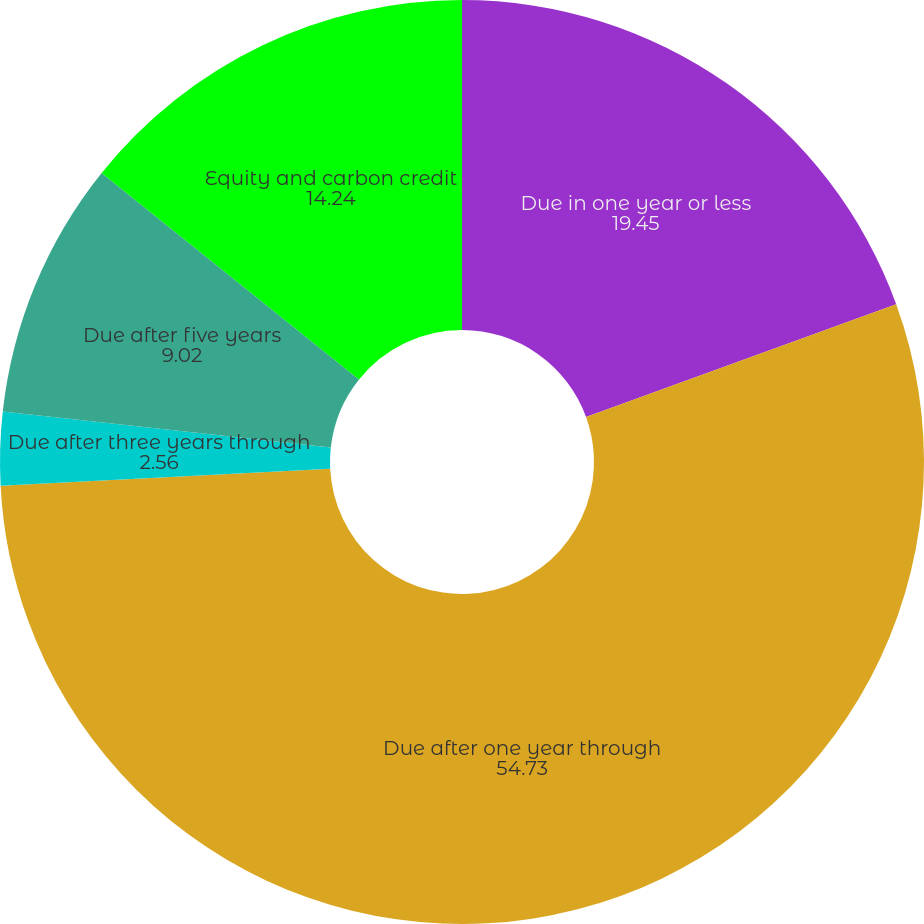<chart> <loc_0><loc_0><loc_500><loc_500><pie_chart><fcel>Due in one year or less<fcel>Due after one year through<fcel>Due after three years through<fcel>Due after five years<fcel>Equity and carbon credit<nl><fcel>19.45%<fcel>54.73%<fcel>2.56%<fcel>9.02%<fcel>14.24%<nl></chart> 